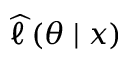<formula> <loc_0><loc_0><loc_500><loc_500>{ \widehat { \ell \, } } ( \theta | x )</formula> 